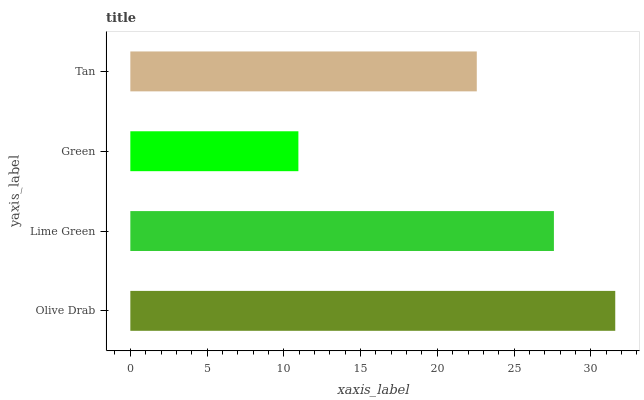Is Green the minimum?
Answer yes or no. Yes. Is Olive Drab the maximum?
Answer yes or no. Yes. Is Lime Green the minimum?
Answer yes or no. No. Is Lime Green the maximum?
Answer yes or no. No. Is Olive Drab greater than Lime Green?
Answer yes or no. Yes. Is Lime Green less than Olive Drab?
Answer yes or no. Yes. Is Lime Green greater than Olive Drab?
Answer yes or no. No. Is Olive Drab less than Lime Green?
Answer yes or no. No. Is Lime Green the high median?
Answer yes or no. Yes. Is Tan the low median?
Answer yes or no. Yes. Is Tan the high median?
Answer yes or no. No. Is Lime Green the low median?
Answer yes or no. No. 